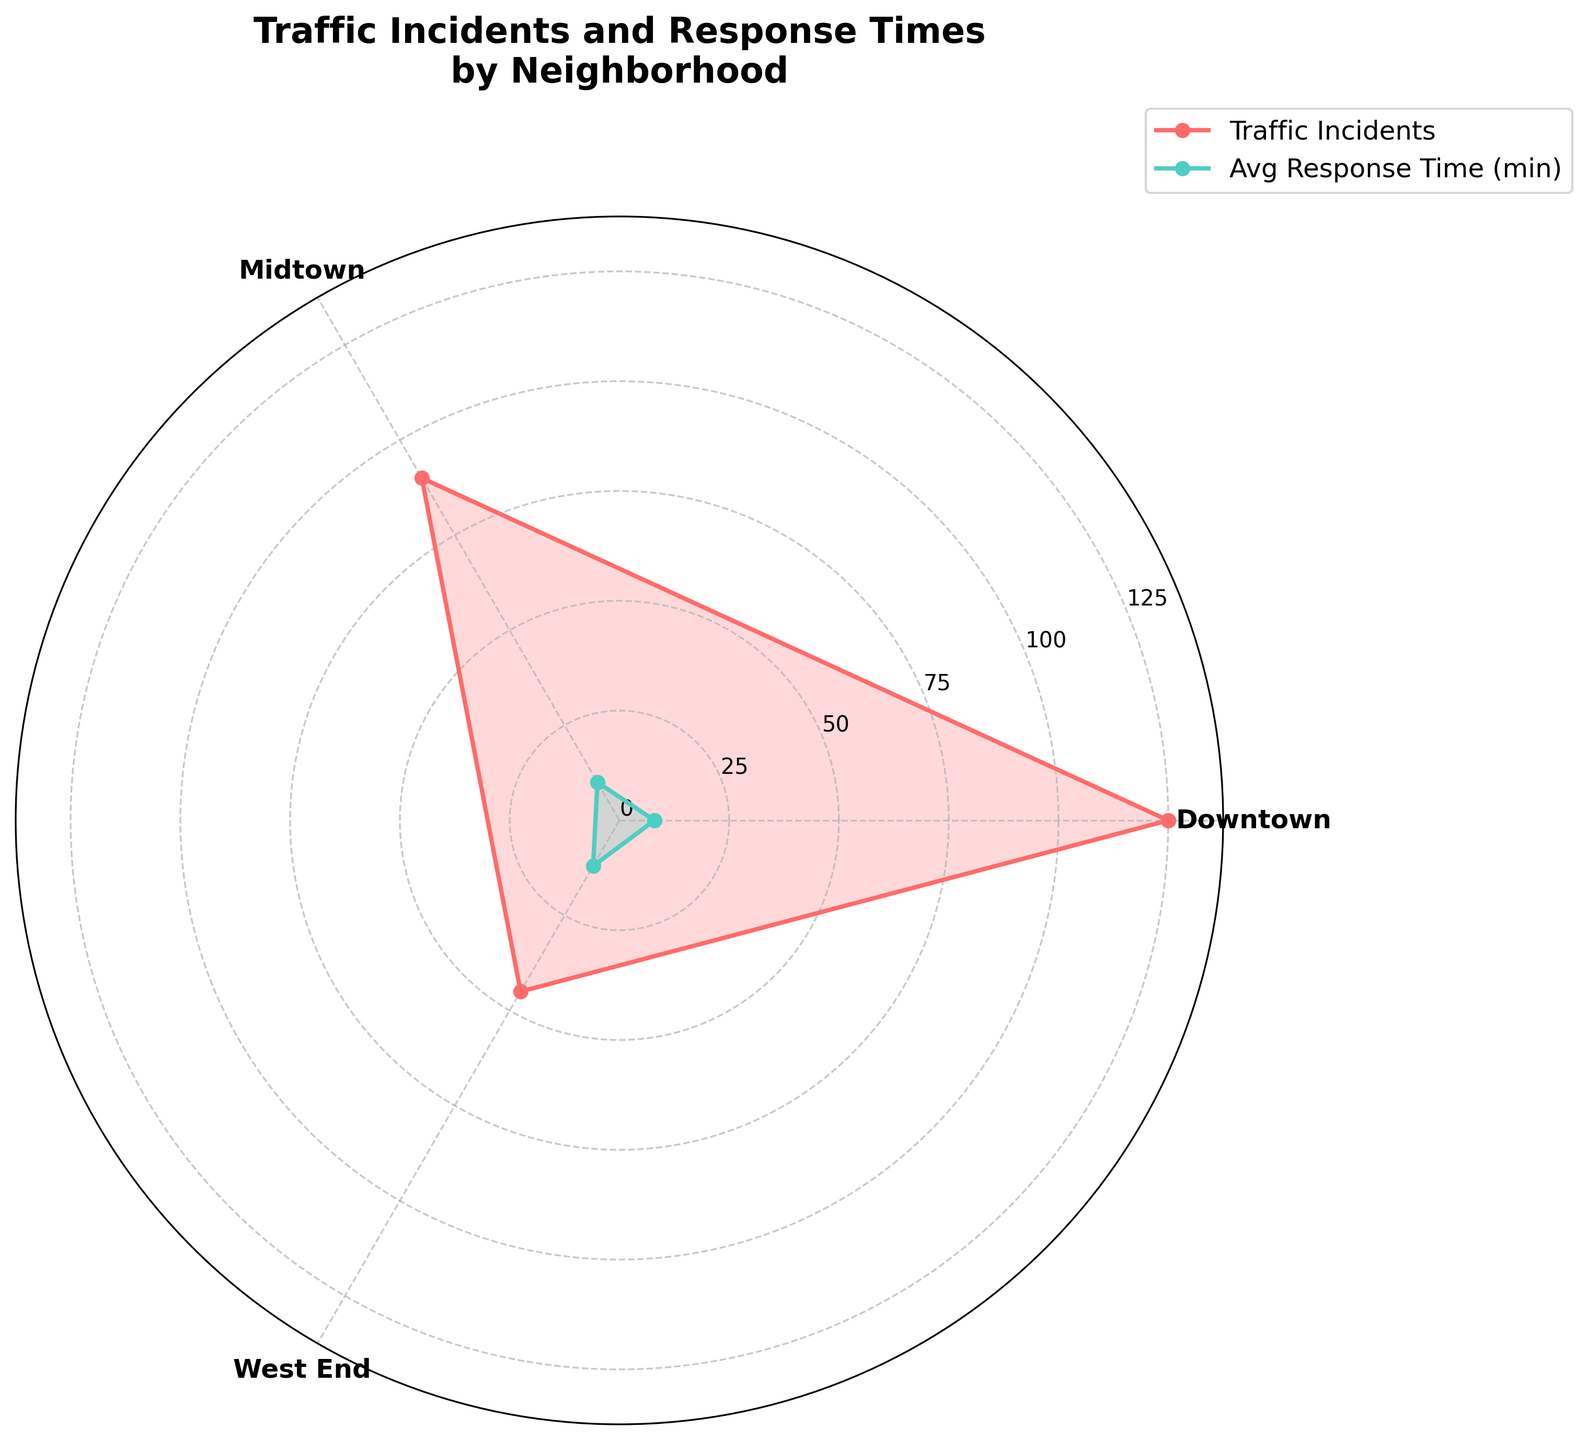How many neighborhoods are compared in the plot? The plot involves selecting the first three neighborhoods from the data to generate the rose chart. By counting the neighborhood labels on the x-axis, we see that there are three neighborhoods included: Downtown, Midtown, and West End.
Answer: Three What is the average response time in Midtown? The average response time for Midtown can be identified by the green line on the graph that represents average response times. Given that the plot encompasses Midtown, the response time is marked on the radial axis. By examining the graph, you can see the green line pointing to 10 minutes for Midtown.
Answer: 10 minutes Which neighborhood has the highest number of traffic incidents? By checking the peaks of the red line, which represents traffic incidents, and their correspondingly labeled neighborhood names on the x-axis, it is clear that Downtown has the highest number of traffic incidents.
Answer: Downtown Which neighborhood has a longer average response time, Midtown or West End? Comparing the green lines for Midtown and West End, which depict average response times, it is apparent that West End's line extends further from the center than Midtown's, indicating a longer response time of 12 minutes compared to Midtown's 10 minutes.
Answer: West End How do the traffic incidents in Downtown compare to those in Midtown? Referring to the red lines for Downtown and Midtown on the plot, you can see that Downtown's value (125 incidents) is higher than Midtown's value (90 incidents).
Answer: Downtown has more traffic incidents than Midtown What's the difference in average response time between Downtown and Midtown? By reviewing the green lines corresponding to the average response times for Downtown and Midtown, it is noted that Downtown has an 8-minute response time, and Midtown has a 10-minute response time. Thus, the difference is 10 - 8 = 2 minutes.
Answer: 2 minutes Which neighborhood has the smallest number of traffic incidents among the three shown? The plot uses red lines to indicate traffic incidents, and the label with the smallest extension from the center is for West End, showing 45 incidents.
Answer: West End Is there a neighborhood where both traffic incidents and response times are the highest? By identifying the highest peaks of both the red and green lines, it is clear that no single neighborhood has the highest values in both traffic incidents and average response times. Downtown has the highest traffic incidents, and West End has the longest response time.
Answer: No What is the sum of traffic incidents across all three neighborhoods on the chart? By taking the values for traffic incidents from Downtown (125), Midtown (90), and West End (45) and adding them together: 125 + 90 + 45 = 260.
Answer: 260 Does Midtown have a larger average response time than Downtown but a smaller one compared to West End? By examining the green lines, Midtown has a 10-minute response time which is greater than Downtown's 8-minute and less than West End's 12-minute response time, confirming the statement.
Answer: Yes 